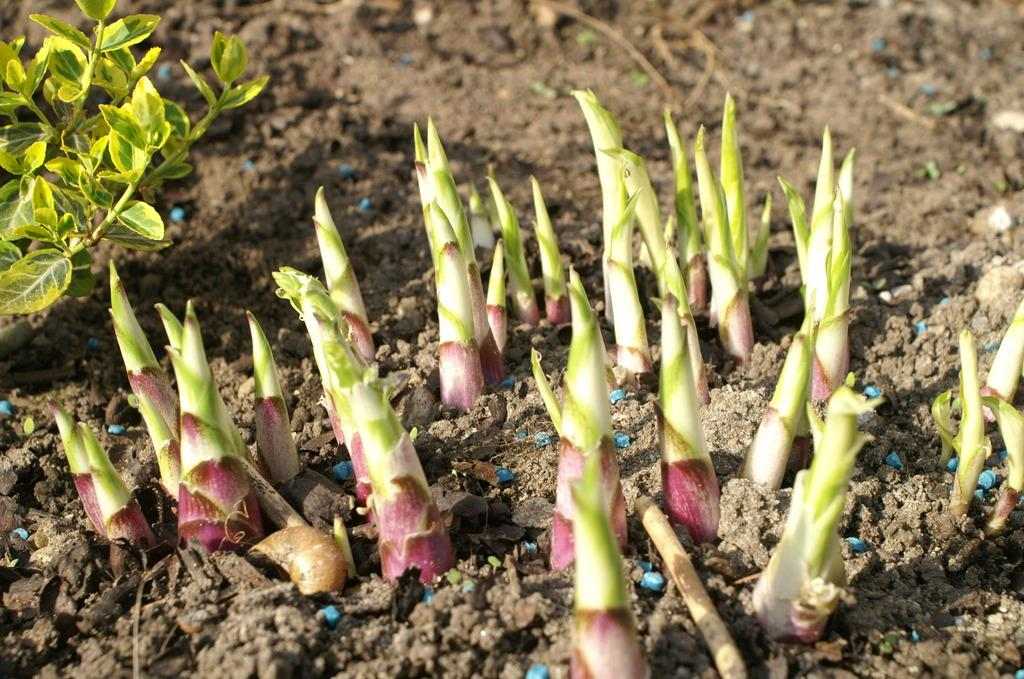What is growing out of the soil in the image? There are small sprouts coming out from the soil in the image. What can be seen on the left side of the image? There is a plant on the left side of the image. What type of foot can be seen on the plant in the image? There are no feet present in the image; it features a plant with small sprouts coming out of the soil. What does the plant in the image sound like? Plants do not have a voice or make sounds, so it is not possible to answer that question based on the image. 